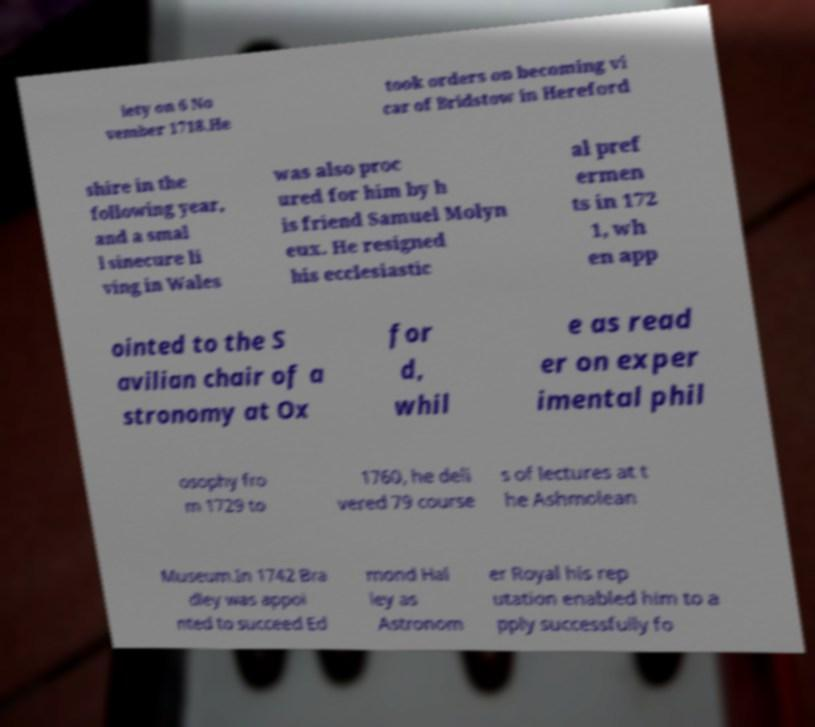Can you accurately transcribe the text from the provided image for me? iety on 6 No vember 1718.He took orders on becoming vi car of Bridstow in Hereford shire in the following year, and a smal l sinecure li ving in Wales was also proc ured for him by h is friend Samuel Molyn eux. He resigned his ecclesiastic al pref ermen ts in 172 1, wh en app ointed to the S avilian chair of a stronomy at Ox for d, whil e as read er on exper imental phil osophy fro m 1729 to 1760, he deli vered 79 course s of lectures at t he Ashmolean Museum.In 1742 Bra dley was appoi nted to succeed Ed mond Hal ley as Astronom er Royal his rep utation enabled him to a pply successfully fo 